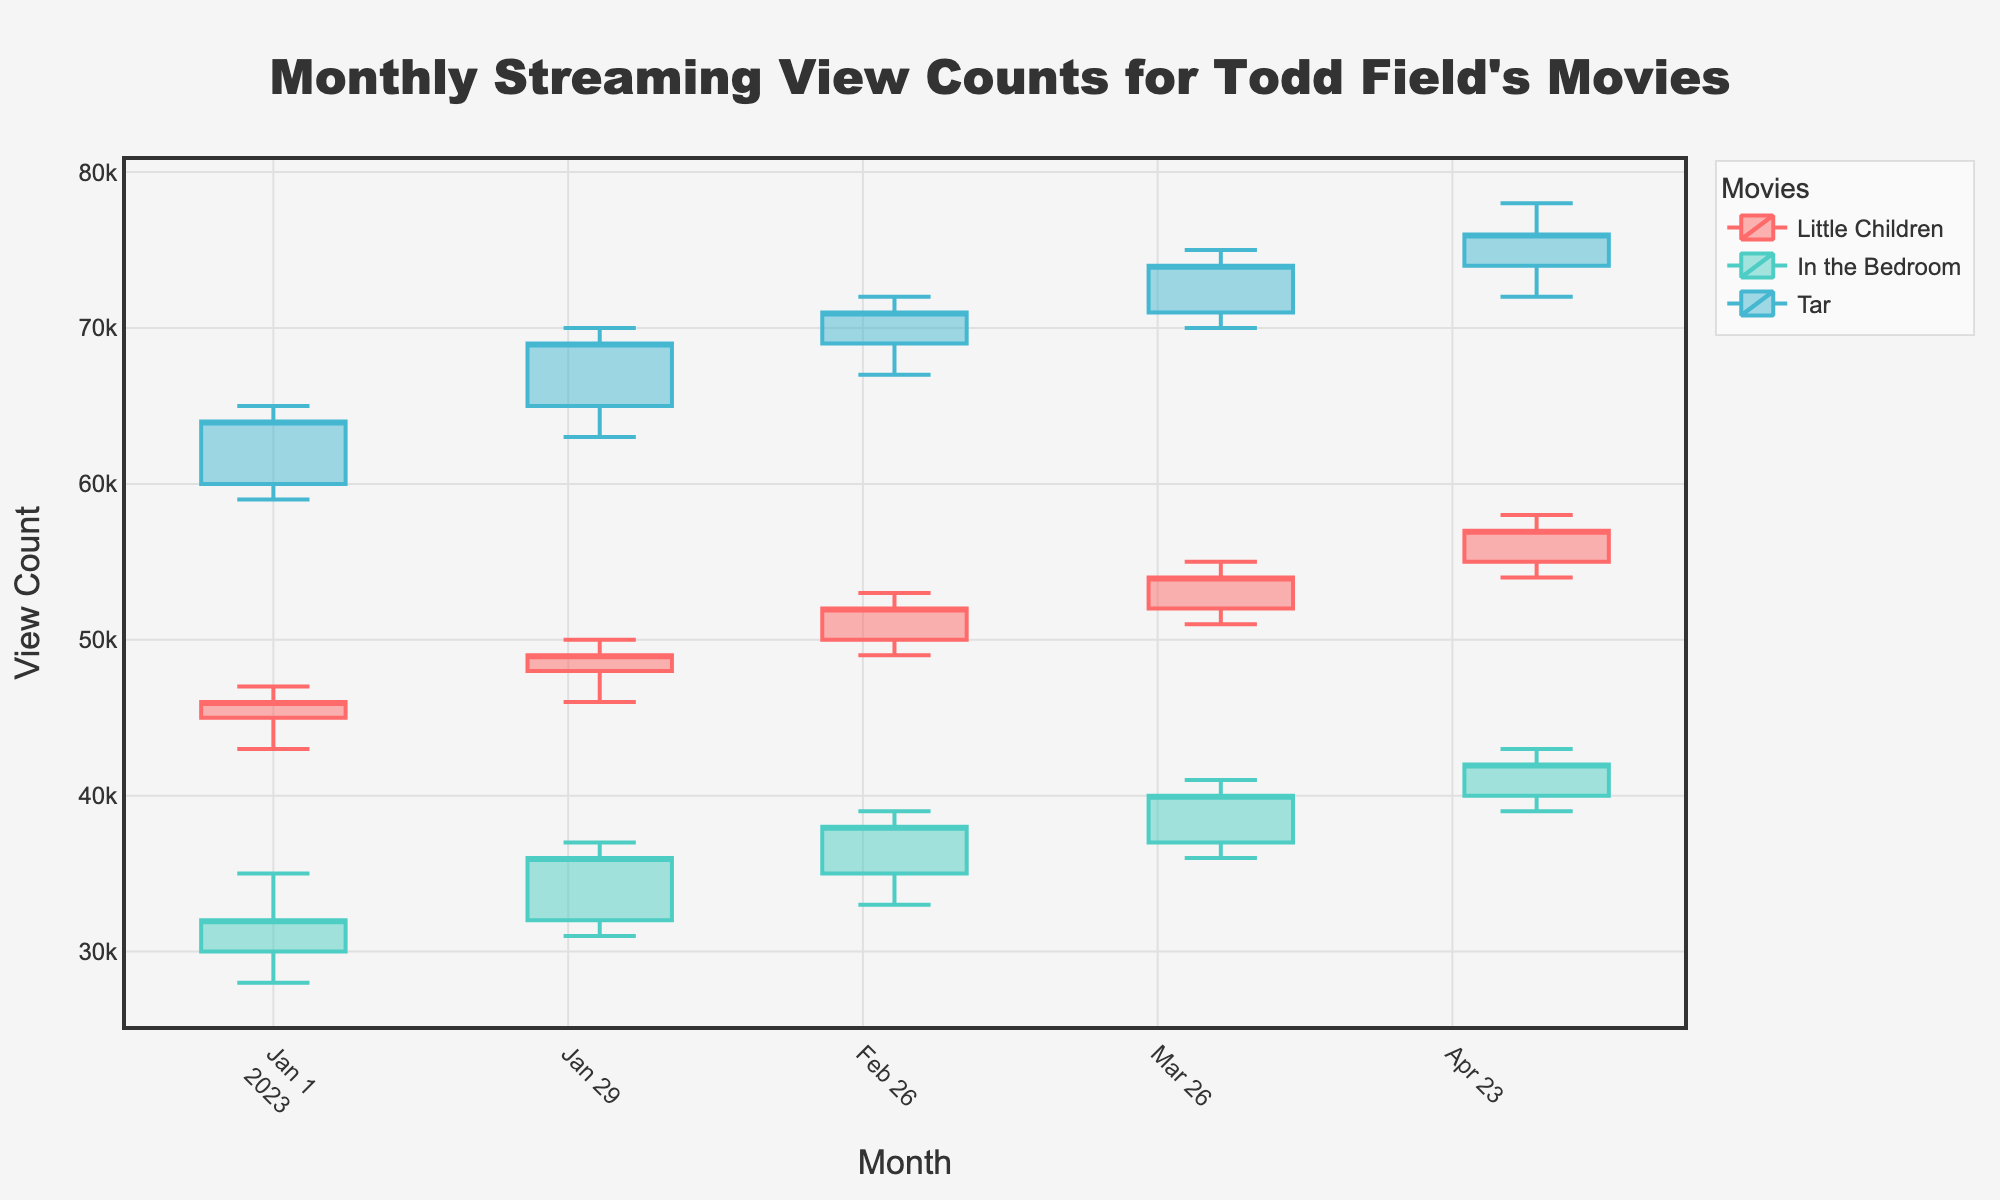What is the title of the plot? The title is usually seen at the top center of the figure. In this case, it tells us what the plot is about.
Answer: Monthly Streaming View Counts for Todd Field's Movies What are the unique streaming platforms featured in the plot? By observing the plot, you can see that different color-coded candlesticks represent different platforms where the movies are streamed.
Answer: Netflix, Hulu, Amazon Prime Which movie had the highest closing view count in May 2023? To find this, look for the highest 'Close' value among the candlesticks corresponding to May 2023 for each movie.
Answer: Tar What is the general trend of view counts for "Little Children" from January to May 2023? To determine this, check the 'Close' values for each candlestick corresponding to "Little Children" across the months. By observing the trend, one can see if it is increasing, decreasing, or fluctuating.
Answer: Increasing What is the total range of view counts for "In the Bedroom" on Hulu in February 2023? The range is found by subtracting the 'Low' value from the 'High' value for the candlestick of "In the Bedroom" in February 2023.
Answer: 6000 Which movie had the smallest difference between its highest and lowest view counts in any month? This requires identifying the smallest difference between 'High' and 'Low' values for any movie in any month. One needs to do this calculation for each candlestick and compare the differences.
Answer: Little Children in January 2023 From February to March 2023, which movie experienced the largest increase in closing view counts? Subtract the 'Close' value of each movie in February from its 'Close' value in March. Identify the movie with the largest positive difference.
Answer: Tar How did the view count for "Tar" change from its opening to closing in April 2023? To determine this, look at the 'Open' and 'Close' values of "Tar" for April 2023 and calculate the difference between them.
Answer: Increased by 3000 What is the median closing view count for "In the Bedroom" during the period from January to May 2023? To find the median, list the 'Close' values for "In the Bedroom" from January to May, sort them, and pick the middle one (or average the two middle ones if there is an even number). The 'Close' values are [32000, 36000, 38000, 40000, 42000], so the median is the middle value.
Answer: 38000 Which movie had the highest opening view count in January 2023? Look at the candlestick plot for January 2023 and compare the 'Open' values of each movie. Identify the one with the highest value.
Answer: Tar 